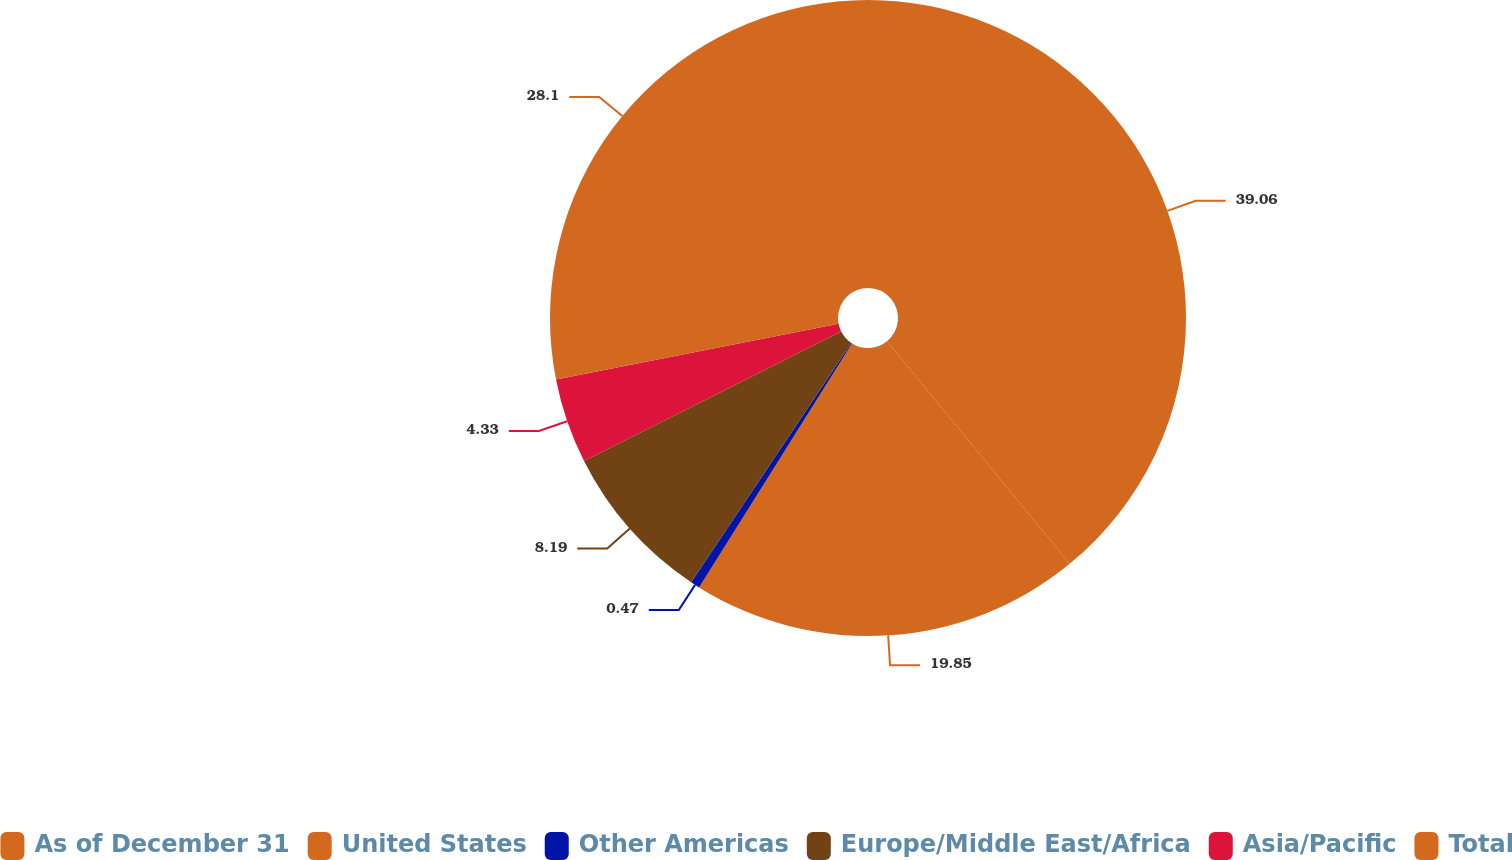Convert chart to OTSL. <chart><loc_0><loc_0><loc_500><loc_500><pie_chart><fcel>As of December 31<fcel>United States<fcel>Other Americas<fcel>Europe/Middle East/Africa<fcel>Asia/Pacific<fcel>Total<nl><fcel>39.07%<fcel>19.85%<fcel>0.47%<fcel>8.19%<fcel>4.33%<fcel>28.1%<nl></chart> 